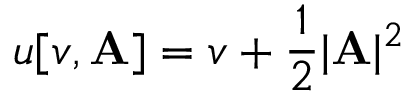<formula> <loc_0><loc_0><loc_500><loc_500>u [ v , A ] = v + \frac { 1 } { 2 } | A | ^ { 2 }</formula> 